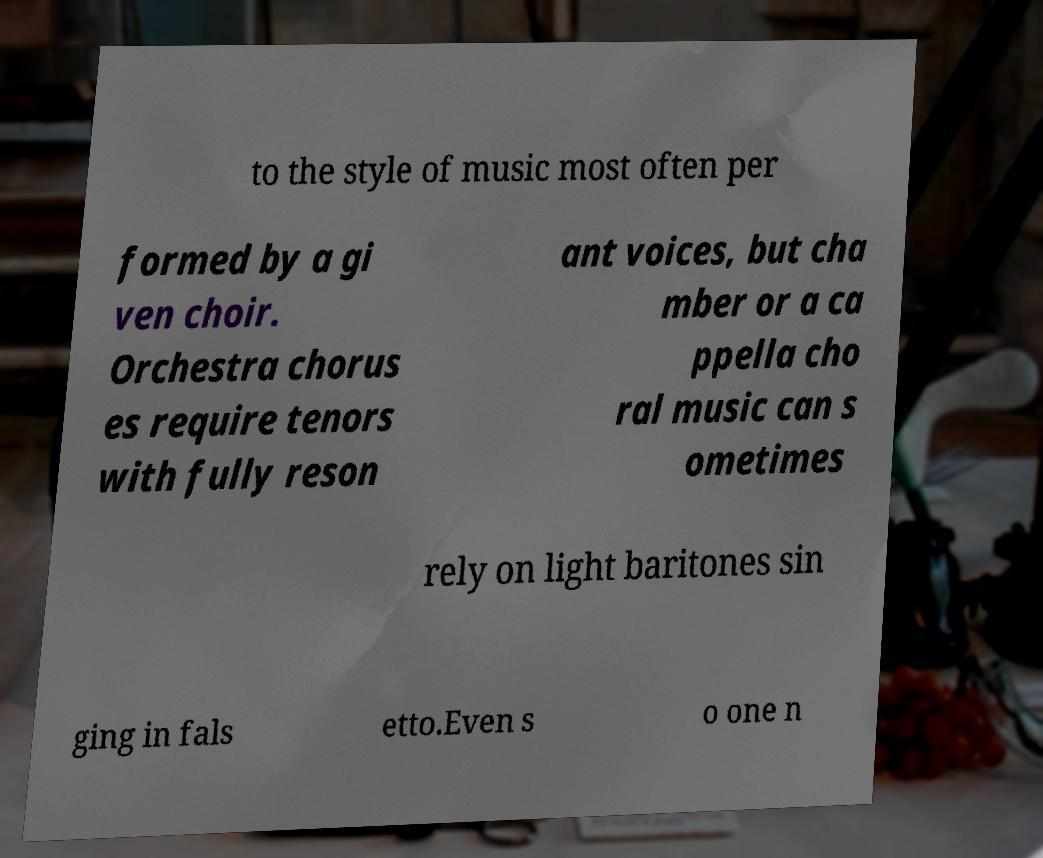Can you read and provide the text displayed in the image?This photo seems to have some interesting text. Can you extract and type it out for me? to the style of music most often per formed by a gi ven choir. Orchestra chorus es require tenors with fully reson ant voices, but cha mber or a ca ppella cho ral music can s ometimes rely on light baritones sin ging in fals etto.Even s o one n 